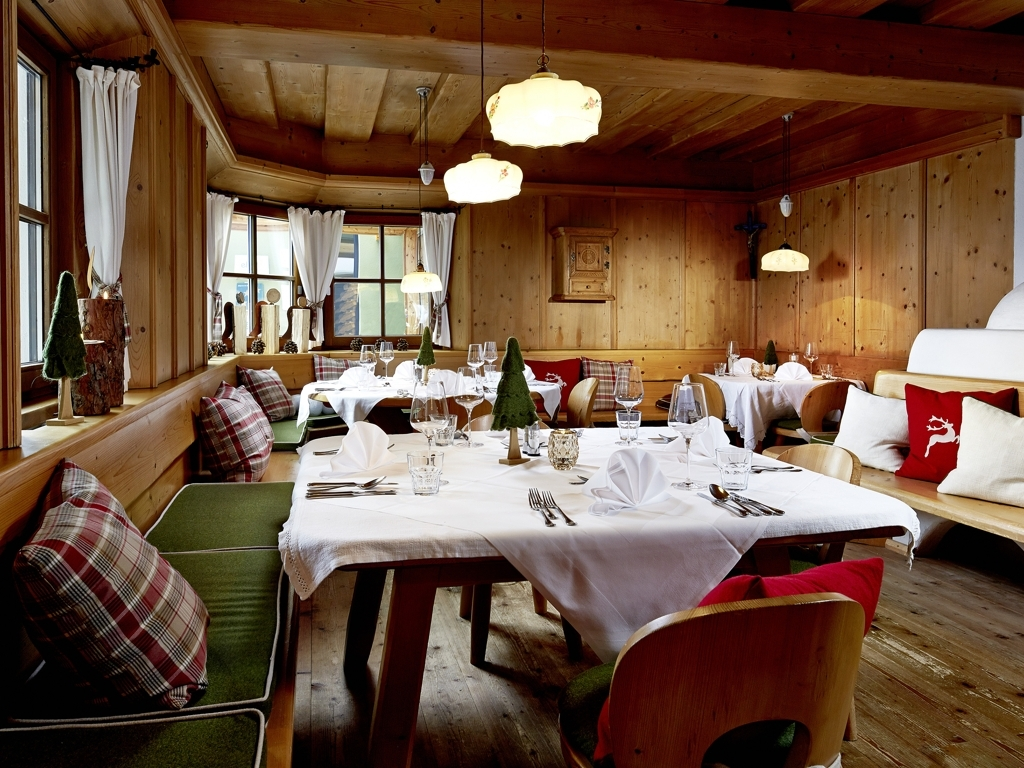How clear is the shooting scene? The image depicts a well-lit, cozy, and inviting dining area that is captured with clarity. The details in the scene are crisp and meticulously arranged, providing a strong visual appeal. From the wooden textures to the checkered and solid-colored cushions adorning the seating area, and even to the elegant table settings with pristine white linen, everything converges to evoke a sense of warmth and hospitality. The image is focused, with no signs of obstruction or blur, displaying an environment where guests can enjoy a comfortable dining experience. 